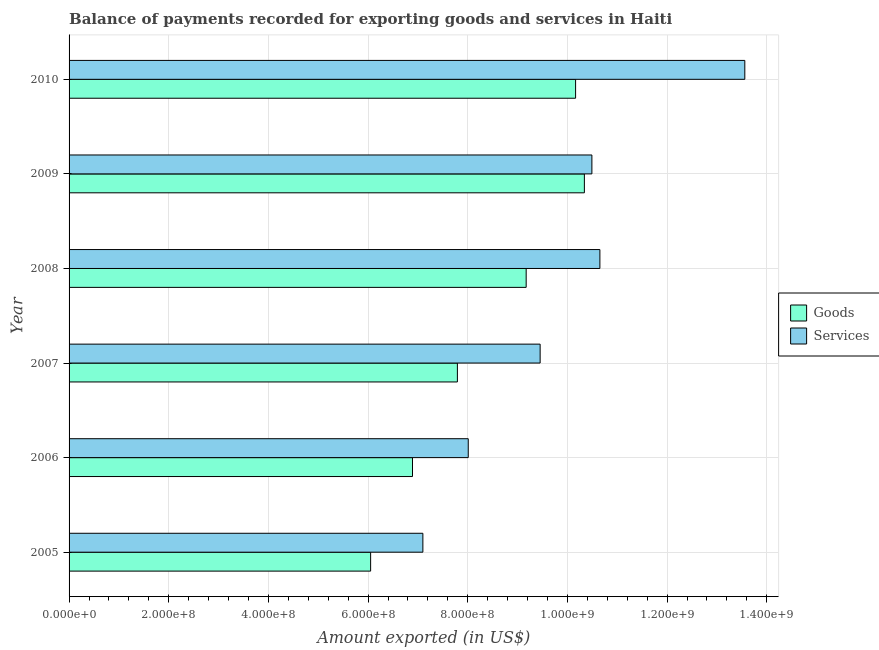How many groups of bars are there?
Offer a terse response. 6. What is the amount of goods exported in 2009?
Make the answer very short. 1.03e+09. Across all years, what is the maximum amount of services exported?
Your answer should be very brief. 1.36e+09. Across all years, what is the minimum amount of goods exported?
Your response must be concise. 6.05e+08. What is the total amount of services exported in the graph?
Provide a succinct answer. 5.93e+09. What is the difference between the amount of goods exported in 2005 and that in 2007?
Keep it short and to the point. -1.74e+08. What is the difference between the amount of goods exported in 2008 and the amount of services exported in 2005?
Make the answer very short. 2.07e+08. What is the average amount of services exported per year?
Provide a succinct answer. 9.88e+08. In the year 2006, what is the difference between the amount of goods exported and amount of services exported?
Make the answer very short. -1.12e+08. In how many years, is the amount of goods exported greater than 160000000 US$?
Keep it short and to the point. 6. What is the ratio of the amount of services exported in 2006 to that in 2010?
Offer a terse response. 0.59. Is the difference between the amount of goods exported in 2006 and 2008 greater than the difference between the amount of services exported in 2006 and 2008?
Ensure brevity in your answer.  Yes. What is the difference between the highest and the second highest amount of goods exported?
Make the answer very short. 1.76e+07. What is the difference between the highest and the lowest amount of services exported?
Your answer should be very brief. 6.46e+08. In how many years, is the amount of services exported greater than the average amount of services exported taken over all years?
Make the answer very short. 3. What does the 2nd bar from the top in 2005 represents?
Ensure brevity in your answer.  Goods. What does the 2nd bar from the bottom in 2007 represents?
Provide a succinct answer. Services. How many bars are there?
Give a very brief answer. 12. Are all the bars in the graph horizontal?
Your answer should be very brief. Yes. How many years are there in the graph?
Ensure brevity in your answer.  6. What is the difference between two consecutive major ticks on the X-axis?
Your answer should be compact. 2.00e+08. Are the values on the major ticks of X-axis written in scientific E-notation?
Make the answer very short. Yes. Does the graph contain grids?
Make the answer very short. Yes. How many legend labels are there?
Your answer should be very brief. 2. What is the title of the graph?
Your response must be concise. Balance of payments recorded for exporting goods and services in Haiti. What is the label or title of the X-axis?
Keep it short and to the point. Amount exported (in US$). What is the label or title of the Y-axis?
Provide a succinct answer. Year. What is the Amount exported (in US$) of Goods in 2005?
Make the answer very short. 6.05e+08. What is the Amount exported (in US$) in Services in 2005?
Provide a short and direct response. 7.10e+08. What is the Amount exported (in US$) of Goods in 2006?
Give a very brief answer. 6.89e+08. What is the Amount exported (in US$) in Services in 2006?
Your answer should be compact. 8.01e+08. What is the Amount exported (in US$) in Goods in 2007?
Offer a very short reply. 7.79e+08. What is the Amount exported (in US$) in Services in 2007?
Offer a terse response. 9.45e+08. What is the Amount exported (in US$) in Goods in 2008?
Give a very brief answer. 9.17e+08. What is the Amount exported (in US$) in Services in 2008?
Offer a very short reply. 1.07e+09. What is the Amount exported (in US$) in Goods in 2009?
Provide a short and direct response. 1.03e+09. What is the Amount exported (in US$) in Services in 2009?
Provide a short and direct response. 1.05e+09. What is the Amount exported (in US$) in Goods in 2010?
Your answer should be compact. 1.02e+09. What is the Amount exported (in US$) of Services in 2010?
Offer a very short reply. 1.36e+09. Across all years, what is the maximum Amount exported (in US$) of Goods?
Keep it short and to the point. 1.03e+09. Across all years, what is the maximum Amount exported (in US$) in Services?
Your answer should be compact. 1.36e+09. Across all years, what is the minimum Amount exported (in US$) of Goods?
Your answer should be compact. 6.05e+08. Across all years, what is the minimum Amount exported (in US$) in Services?
Make the answer very short. 7.10e+08. What is the total Amount exported (in US$) in Goods in the graph?
Ensure brevity in your answer.  5.04e+09. What is the total Amount exported (in US$) of Services in the graph?
Ensure brevity in your answer.  5.93e+09. What is the difference between the Amount exported (in US$) in Goods in 2005 and that in 2006?
Ensure brevity in your answer.  -8.40e+07. What is the difference between the Amount exported (in US$) of Services in 2005 and that in 2006?
Give a very brief answer. -9.10e+07. What is the difference between the Amount exported (in US$) in Goods in 2005 and that in 2007?
Your answer should be very brief. -1.74e+08. What is the difference between the Amount exported (in US$) of Services in 2005 and that in 2007?
Make the answer very short. -2.35e+08. What is the difference between the Amount exported (in US$) in Goods in 2005 and that in 2008?
Give a very brief answer. -3.12e+08. What is the difference between the Amount exported (in US$) of Services in 2005 and that in 2008?
Offer a very short reply. -3.55e+08. What is the difference between the Amount exported (in US$) in Goods in 2005 and that in 2009?
Give a very brief answer. -4.29e+08. What is the difference between the Amount exported (in US$) of Services in 2005 and that in 2009?
Provide a succinct answer. -3.39e+08. What is the difference between the Amount exported (in US$) of Goods in 2005 and that in 2010?
Your answer should be compact. -4.11e+08. What is the difference between the Amount exported (in US$) of Services in 2005 and that in 2010?
Ensure brevity in your answer.  -6.46e+08. What is the difference between the Amount exported (in US$) in Goods in 2006 and that in 2007?
Your answer should be very brief. -9.01e+07. What is the difference between the Amount exported (in US$) in Services in 2006 and that in 2007?
Offer a terse response. -1.44e+08. What is the difference between the Amount exported (in US$) of Goods in 2006 and that in 2008?
Your answer should be compact. -2.28e+08. What is the difference between the Amount exported (in US$) in Services in 2006 and that in 2008?
Provide a short and direct response. -2.64e+08. What is the difference between the Amount exported (in US$) in Goods in 2006 and that in 2009?
Keep it short and to the point. -3.45e+08. What is the difference between the Amount exported (in US$) of Services in 2006 and that in 2009?
Your response must be concise. -2.48e+08. What is the difference between the Amount exported (in US$) in Goods in 2006 and that in 2010?
Offer a terse response. -3.27e+08. What is the difference between the Amount exported (in US$) in Services in 2006 and that in 2010?
Offer a very short reply. -5.55e+08. What is the difference between the Amount exported (in US$) in Goods in 2007 and that in 2008?
Your answer should be very brief. -1.38e+08. What is the difference between the Amount exported (in US$) in Services in 2007 and that in 2008?
Provide a succinct answer. -1.20e+08. What is the difference between the Amount exported (in US$) of Goods in 2007 and that in 2009?
Give a very brief answer. -2.55e+08. What is the difference between the Amount exported (in US$) of Services in 2007 and that in 2009?
Make the answer very short. -1.04e+08. What is the difference between the Amount exported (in US$) of Goods in 2007 and that in 2010?
Provide a short and direct response. -2.37e+08. What is the difference between the Amount exported (in US$) of Services in 2007 and that in 2010?
Provide a short and direct response. -4.11e+08. What is the difference between the Amount exported (in US$) in Goods in 2008 and that in 2009?
Give a very brief answer. -1.17e+08. What is the difference between the Amount exported (in US$) of Services in 2008 and that in 2009?
Give a very brief answer. 1.60e+07. What is the difference between the Amount exported (in US$) in Goods in 2008 and that in 2010?
Offer a very short reply. -9.92e+07. What is the difference between the Amount exported (in US$) of Services in 2008 and that in 2010?
Keep it short and to the point. -2.91e+08. What is the difference between the Amount exported (in US$) in Goods in 2009 and that in 2010?
Offer a terse response. 1.76e+07. What is the difference between the Amount exported (in US$) of Services in 2009 and that in 2010?
Make the answer very short. -3.07e+08. What is the difference between the Amount exported (in US$) of Goods in 2005 and the Amount exported (in US$) of Services in 2006?
Your response must be concise. -1.96e+08. What is the difference between the Amount exported (in US$) in Goods in 2005 and the Amount exported (in US$) in Services in 2007?
Give a very brief answer. -3.40e+08. What is the difference between the Amount exported (in US$) in Goods in 2005 and the Amount exported (in US$) in Services in 2008?
Ensure brevity in your answer.  -4.60e+08. What is the difference between the Amount exported (in US$) of Goods in 2005 and the Amount exported (in US$) of Services in 2009?
Ensure brevity in your answer.  -4.44e+08. What is the difference between the Amount exported (in US$) in Goods in 2005 and the Amount exported (in US$) in Services in 2010?
Keep it short and to the point. -7.51e+08. What is the difference between the Amount exported (in US$) of Goods in 2006 and the Amount exported (in US$) of Services in 2007?
Provide a short and direct response. -2.56e+08. What is the difference between the Amount exported (in US$) of Goods in 2006 and the Amount exported (in US$) of Services in 2008?
Offer a terse response. -3.76e+08. What is the difference between the Amount exported (in US$) of Goods in 2006 and the Amount exported (in US$) of Services in 2009?
Offer a very short reply. -3.60e+08. What is the difference between the Amount exported (in US$) in Goods in 2006 and the Amount exported (in US$) in Services in 2010?
Provide a short and direct response. -6.67e+08. What is the difference between the Amount exported (in US$) of Goods in 2007 and the Amount exported (in US$) of Services in 2008?
Make the answer very short. -2.86e+08. What is the difference between the Amount exported (in US$) in Goods in 2007 and the Amount exported (in US$) in Services in 2009?
Your answer should be very brief. -2.70e+08. What is the difference between the Amount exported (in US$) of Goods in 2007 and the Amount exported (in US$) of Services in 2010?
Give a very brief answer. -5.77e+08. What is the difference between the Amount exported (in US$) of Goods in 2008 and the Amount exported (in US$) of Services in 2009?
Your answer should be compact. -1.32e+08. What is the difference between the Amount exported (in US$) in Goods in 2008 and the Amount exported (in US$) in Services in 2010?
Your answer should be very brief. -4.39e+08. What is the difference between the Amount exported (in US$) in Goods in 2009 and the Amount exported (in US$) in Services in 2010?
Keep it short and to the point. -3.22e+08. What is the average Amount exported (in US$) of Goods per year?
Provide a succinct answer. 8.40e+08. What is the average Amount exported (in US$) in Services per year?
Keep it short and to the point. 9.88e+08. In the year 2005, what is the difference between the Amount exported (in US$) of Goods and Amount exported (in US$) of Services?
Your answer should be very brief. -1.05e+08. In the year 2006, what is the difference between the Amount exported (in US$) of Goods and Amount exported (in US$) of Services?
Offer a terse response. -1.12e+08. In the year 2007, what is the difference between the Amount exported (in US$) of Goods and Amount exported (in US$) of Services?
Your answer should be compact. -1.66e+08. In the year 2008, what is the difference between the Amount exported (in US$) of Goods and Amount exported (in US$) of Services?
Ensure brevity in your answer.  -1.48e+08. In the year 2009, what is the difference between the Amount exported (in US$) of Goods and Amount exported (in US$) of Services?
Your answer should be compact. -1.51e+07. In the year 2010, what is the difference between the Amount exported (in US$) in Goods and Amount exported (in US$) in Services?
Your answer should be very brief. -3.40e+08. What is the ratio of the Amount exported (in US$) in Goods in 2005 to that in 2006?
Offer a terse response. 0.88. What is the ratio of the Amount exported (in US$) in Services in 2005 to that in 2006?
Make the answer very short. 0.89. What is the ratio of the Amount exported (in US$) in Goods in 2005 to that in 2007?
Provide a short and direct response. 0.78. What is the ratio of the Amount exported (in US$) in Services in 2005 to that in 2007?
Your answer should be very brief. 0.75. What is the ratio of the Amount exported (in US$) of Goods in 2005 to that in 2008?
Your answer should be compact. 0.66. What is the ratio of the Amount exported (in US$) in Services in 2005 to that in 2008?
Offer a very short reply. 0.67. What is the ratio of the Amount exported (in US$) of Goods in 2005 to that in 2009?
Give a very brief answer. 0.59. What is the ratio of the Amount exported (in US$) in Services in 2005 to that in 2009?
Ensure brevity in your answer.  0.68. What is the ratio of the Amount exported (in US$) of Goods in 2005 to that in 2010?
Ensure brevity in your answer.  0.6. What is the ratio of the Amount exported (in US$) of Services in 2005 to that in 2010?
Ensure brevity in your answer.  0.52. What is the ratio of the Amount exported (in US$) in Goods in 2006 to that in 2007?
Offer a very short reply. 0.88. What is the ratio of the Amount exported (in US$) of Services in 2006 to that in 2007?
Offer a terse response. 0.85. What is the ratio of the Amount exported (in US$) in Goods in 2006 to that in 2008?
Offer a terse response. 0.75. What is the ratio of the Amount exported (in US$) in Services in 2006 to that in 2008?
Your answer should be very brief. 0.75. What is the ratio of the Amount exported (in US$) in Goods in 2006 to that in 2009?
Give a very brief answer. 0.67. What is the ratio of the Amount exported (in US$) of Services in 2006 to that in 2009?
Keep it short and to the point. 0.76. What is the ratio of the Amount exported (in US$) in Goods in 2006 to that in 2010?
Your answer should be very brief. 0.68. What is the ratio of the Amount exported (in US$) of Services in 2006 to that in 2010?
Give a very brief answer. 0.59. What is the ratio of the Amount exported (in US$) of Goods in 2007 to that in 2008?
Offer a terse response. 0.85. What is the ratio of the Amount exported (in US$) in Services in 2007 to that in 2008?
Provide a short and direct response. 0.89. What is the ratio of the Amount exported (in US$) in Goods in 2007 to that in 2009?
Make the answer very short. 0.75. What is the ratio of the Amount exported (in US$) of Services in 2007 to that in 2009?
Provide a succinct answer. 0.9. What is the ratio of the Amount exported (in US$) of Goods in 2007 to that in 2010?
Provide a succinct answer. 0.77. What is the ratio of the Amount exported (in US$) in Services in 2007 to that in 2010?
Offer a very short reply. 0.7. What is the ratio of the Amount exported (in US$) of Goods in 2008 to that in 2009?
Your response must be concise. 0.89. What is the ratio of the Amount exported (in US$) of Services in 2008 to that in 2009?
Provide a succinct answer. 1.02. What is the ratio of the Amount exported (in US$) in Goods in 2008 to that in 2010?
Ensure brevity in your answer.  0.9. What is the ratio of the Amount exported (in US$) in Services in 2008 to that in 2010?
Provide a succinct answer. 0.79. What is the ratio of the Amount exported (in US$) of Goods in 2009 to that in 2010?
Keep it short and to the point. 1.02. What is the ratio of the Amount exported (in US$) of Services in 2009 to that in 2010?
Your answer should be very brief. 0.77. What is the difference between the highest and the second highest Amount exported (in US$) in Goods?
Provide a succinct answer. 1.76e+07. What is the difference between the highest and the second highest Amount exported (in US$) of Services?
Your answer should be very brief. 2.91e+08. What is the difference between the highest and the lowest Amount exported (in US$) of Goods?
Keep it short and to the point. 4.29e+08. What is the difference between the highest and the lowest Amount exported (in US$) of Services?
Ensure brevity in your answer.  6.46e+08. 